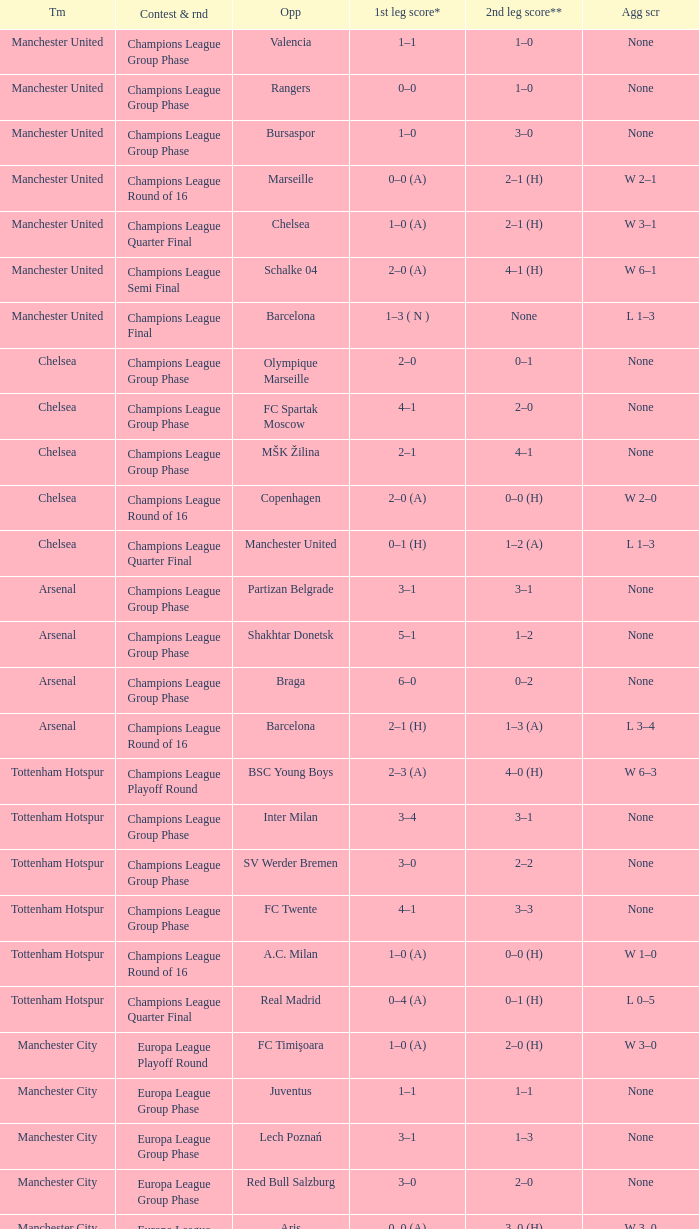What was the score between Marseille and Manchester United on the second leg of the Champions League Round of 16? 2–1 (H). 